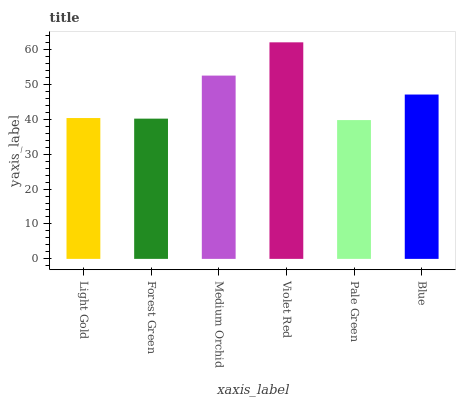Is Pale Green the minimum?
Answer yes or no. Yes. Is Violet Red the maximum?
Answer yes or no. Yes. Is Forest Green the minimum?
Answer yes or no. No. Is Forest Green the maximum?
Answer yes or no. No. Is Light Gold greater than Forest Green?
Answer yes or no. Yes. Is Forest Green less than Light Gold?
Answer yes or no. Yes. Is Forest Green greater than Light Gold?
Answer yes or no. No. Is Light Gold less than Forest Green?
Answer yes or no. No. Is Blue the high median?
Answer yes or no. Yes. Is Light Gold the low median?
Answer yes or no. Yes. Is Violet Red the high median?
Answer yes or no. No. Is Pale Green the low median?
Answer yes or no. No. 